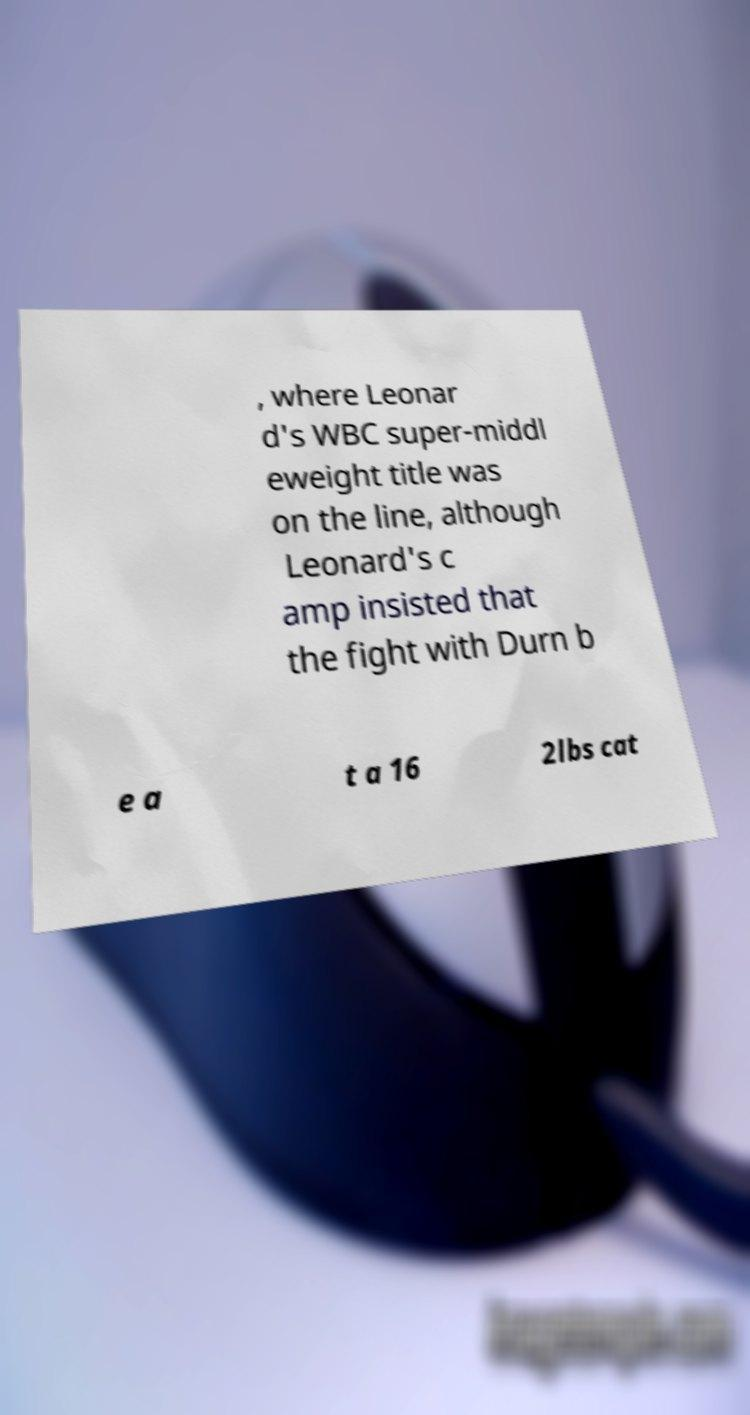Can you accurately transcribe the text from the provided image for me? , where Leonar d's WBC super-middl eweight title was on the line, although Leonard's c amp insisted that the fight with Durn b e a t a 16 2lbs cat 